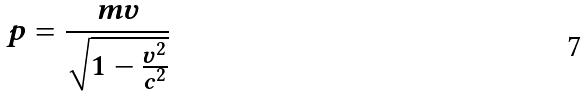Convert formula to latex. <formula><loc_0><loc_0><loc_500><loc_500>p = \frac { m v } { \sqrt { 1 - \frac { v ^ { 2 } } { c ^ { 2 } } } }</formula> 